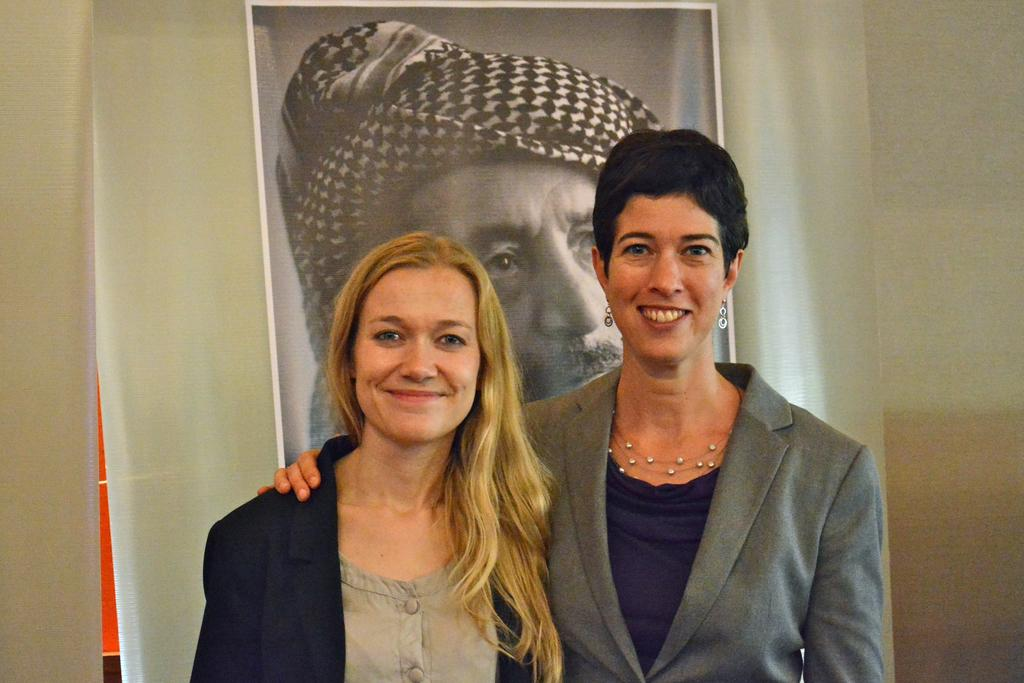How many people are in the image? There are two women in the image. What expressions do the women have? The women are smiling in the image. What can be seen in the background of the image? There is a banner and a plain wall in the background of the image. Can you see any clubs in the image? There are no clubs visible in the image. What type of face paint is the woman wearing on her face? There is no face paint visible on the women's faces in the image. 